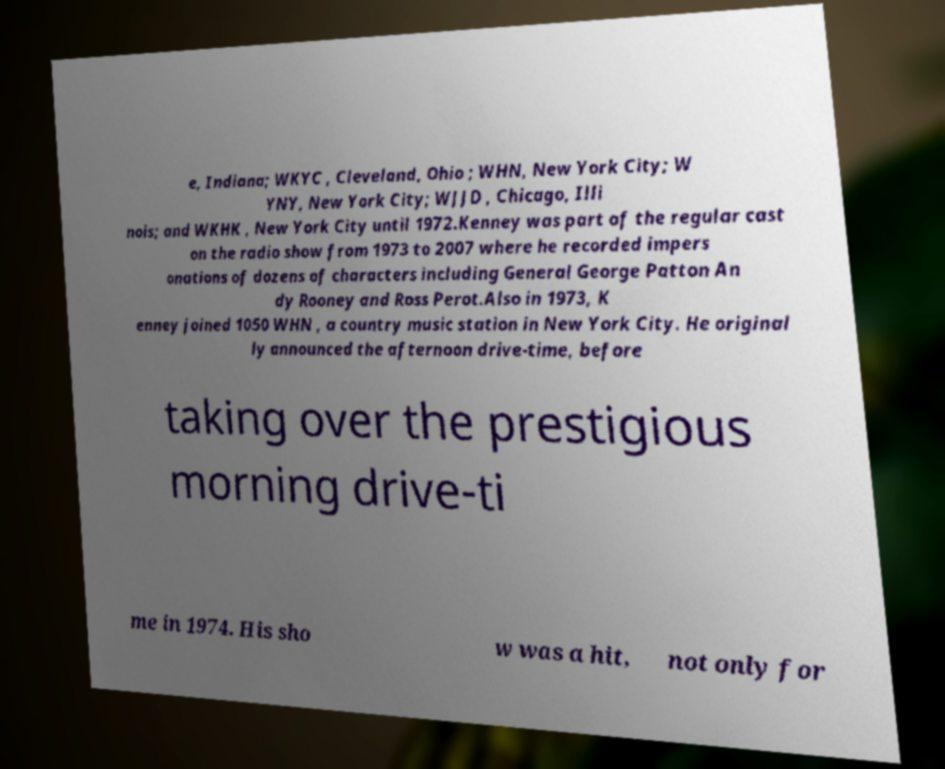Can you accurately transcribe the text from the provided image for me? e, Indiana; WKYC , Cleveland, Ohio ; WHN, New York City; W YNY, New York City; WJJD , Chicago, Illi nois; and WKHK , New York City until 1972.Kenney was part of the regular cast on the radio show from 1973 to 2007 where he recorded impers onations of dozens of characters including General George Patton An dy Rooney and Ross Perot.Also in 1973, K enney joined 1050 WHN , a country music station in New York City. He original ly announced the afternoon drive-time, before taking over the prestigious morning drive-ti me in 1974. His sho w was a hit, not only for 